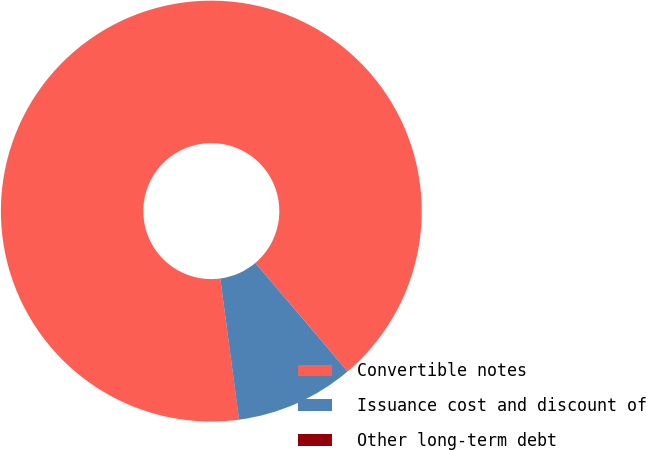<chart> <loc_0><loc_0><loc_500><loc_500><pie_chart><fcel>Convertible notes<fcel>Issuance cost and discount of<fcel>Other long-term debt<nl><fcel>90.88%<fcel>9.1%<fcel>0.01%<nl></chart> 